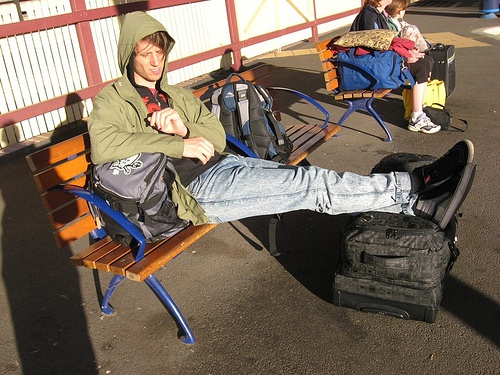Describe the objects in this image and their specific colors. I can see people in tan, lightgray, black, and darkgray tones, bench in tan, black, maroon, gray, and orange tones, backpack in tan, black, darkgray, and gray tones, suitcase in tan, black, and gray tones, and backpack in tan, gray, black, and darkgray tones in this image. 